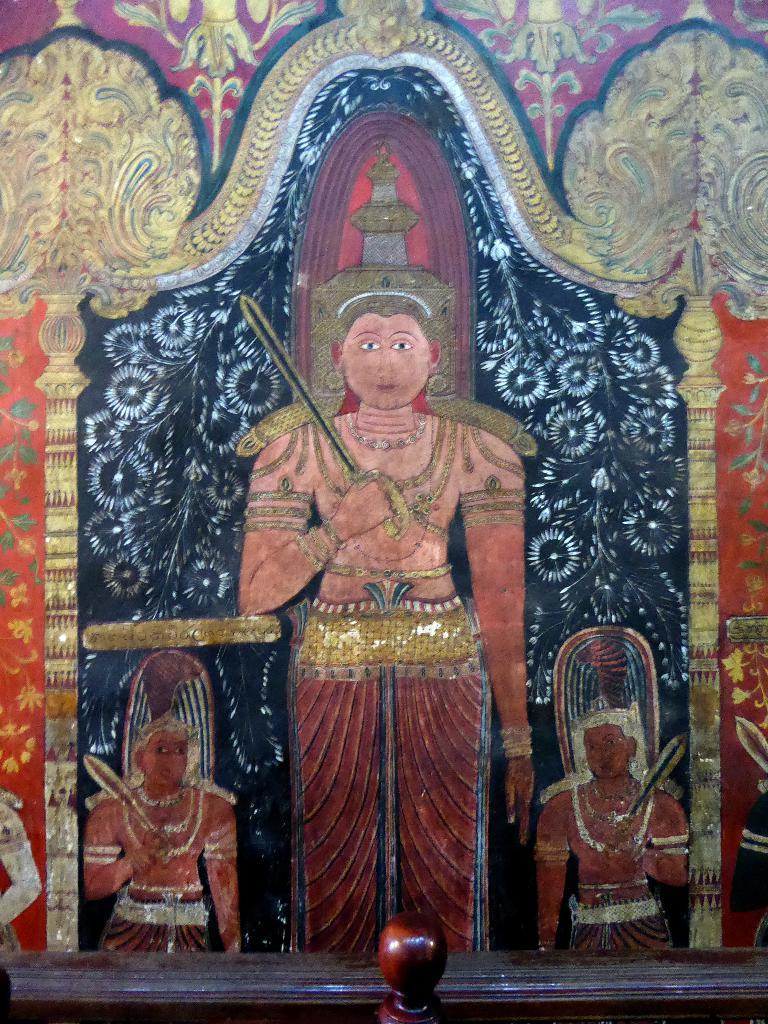What can be seen on the wall in the image? There is artwork on the wall in the image. What is located at the front of the image? There is a small wooden railing in the front of the image. Can you see any ghosts interacting with the artwork in the image? There are no ghosts present in the image, and therefore no such interaction can be observed. What type of pen is being used to create the artwork in the image? The provided facts do not mention any pens or the creation process of the artwork, so it cannot be determined from the image. 